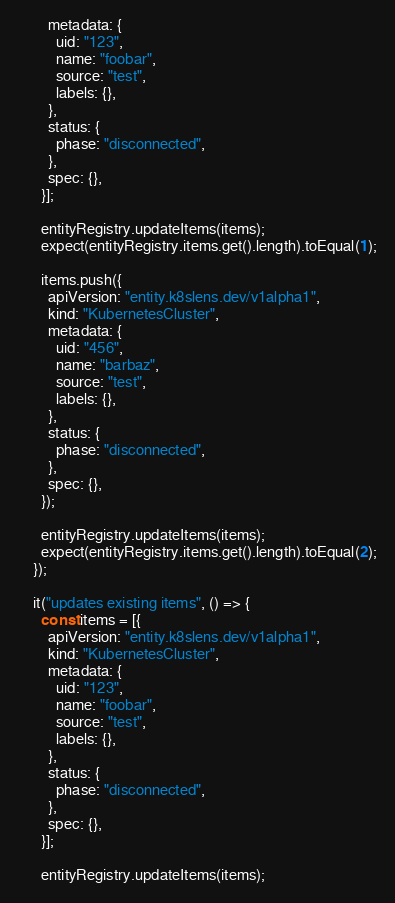Convert code to text. <code><loc_0><loc_0><loc_500><loc_500><_TypeScript_>        metadata: {
          uid: "123",
          name: "foobar",
          source: "test",
          labels: {},
        },
        status: {
          phase: "disconnected",
        },
        spec: {},
      }];

      entityRegistry.updateItems(items);
      expect(entityRegistry.items.get().length).toEqual(1);

      items.push({
        apiVersion: "entity.k8slens.dev/v1alpha1",
        kind: "KubernetesCluster",
        metadata: {
          uid: "456",
          name: "barbaz",
          source: "test",
          labels: {},
        },
        status: {
          phase: "disconnected",
        },
        spec: {},
      });

      entityRegistry.updateItems(items);
      expect(entityRegistry.items.get().length).toEqual(2);
    });

    it("updates existing items", () => {
      const items = [{
        apiVersion: "entity.k8slens.dev/v1alpha1",
        kind: "KubernetesCluster",
        metadata: {
          uid: "123",
          name: "foobar",
          source: "test",
          labels: {},
        },
        status: {
          phase: "disconnected",
        },
        spec: {},
      }];

      entityRegistry.updateItems(items);</code> 